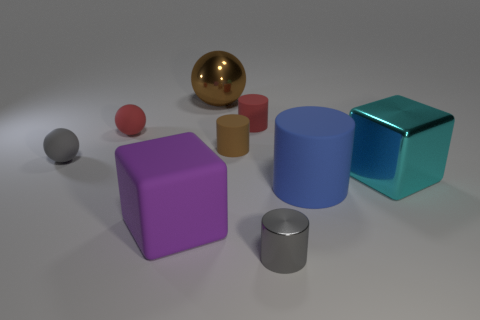Subtract 1 cylinders. How many cylinders are left? 3 Subtract all cylinders. How many objects are left? 5 Add 1 small brown cylinders. How many small brown cylinders are left? 2 Add 2 tiny balls. How many tiny balls exist? 4 Subtract 0 green spheres. How many objects are left? 9 Subtract all large brown metallic blocks. Subtract all large blue rubber cylinders. How many objects are left? 8 